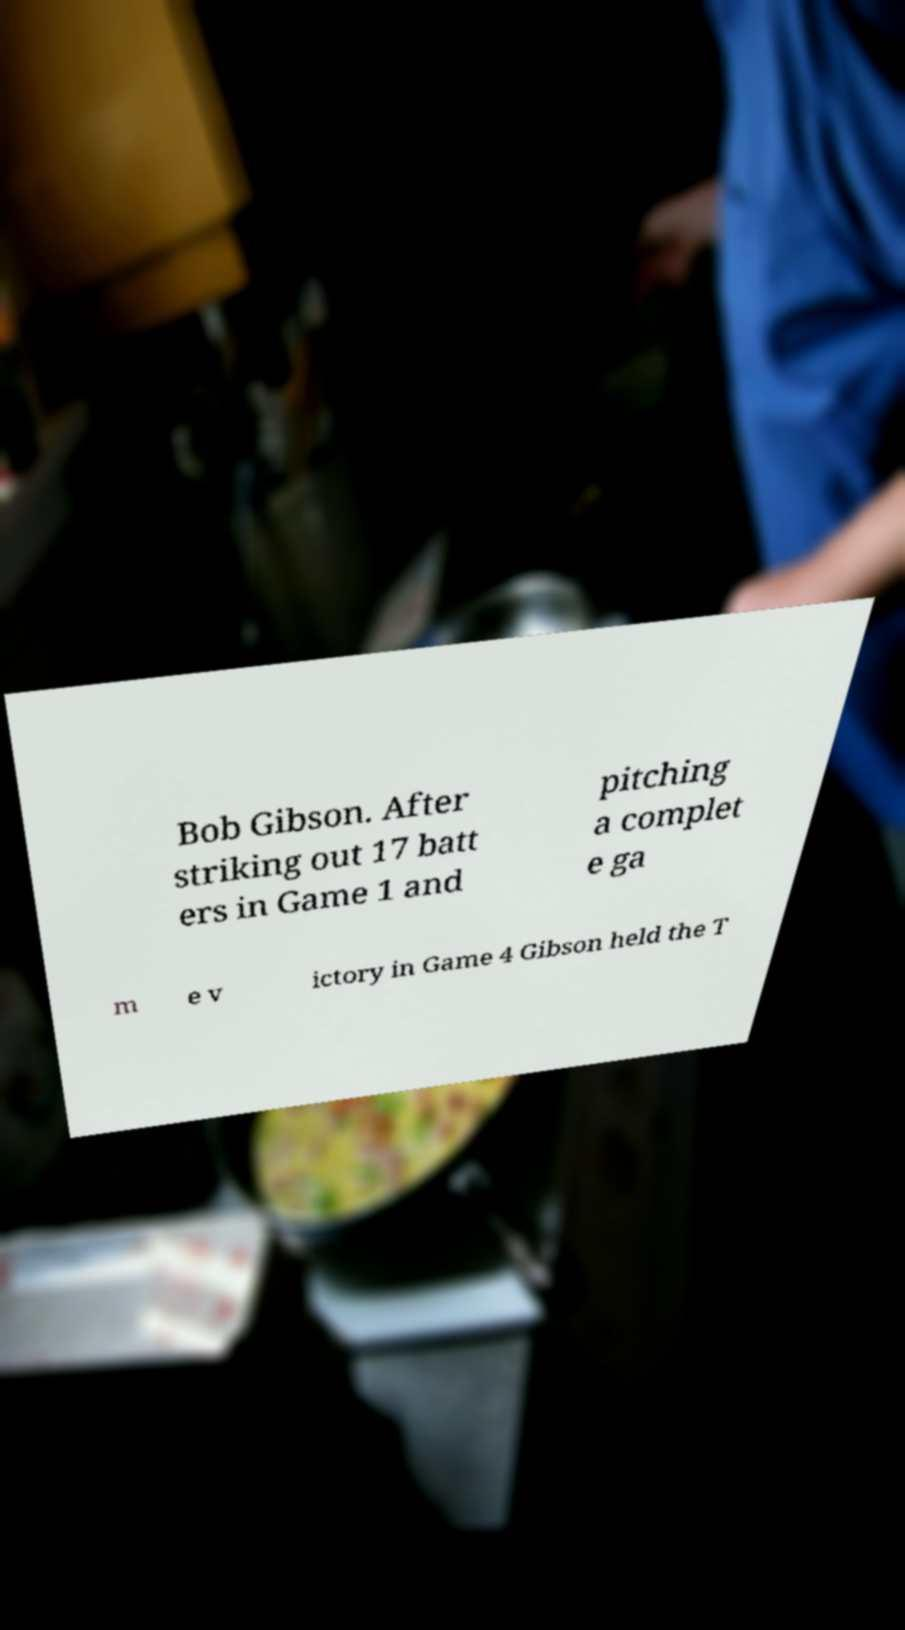Could you assist in decoding the text presented in this image and type it out clearly? Bob Gibson. After striking out 17 batt ers in Game 1 and pitching a complet e ga m e v ictory in Game 4 Gibson held the T 